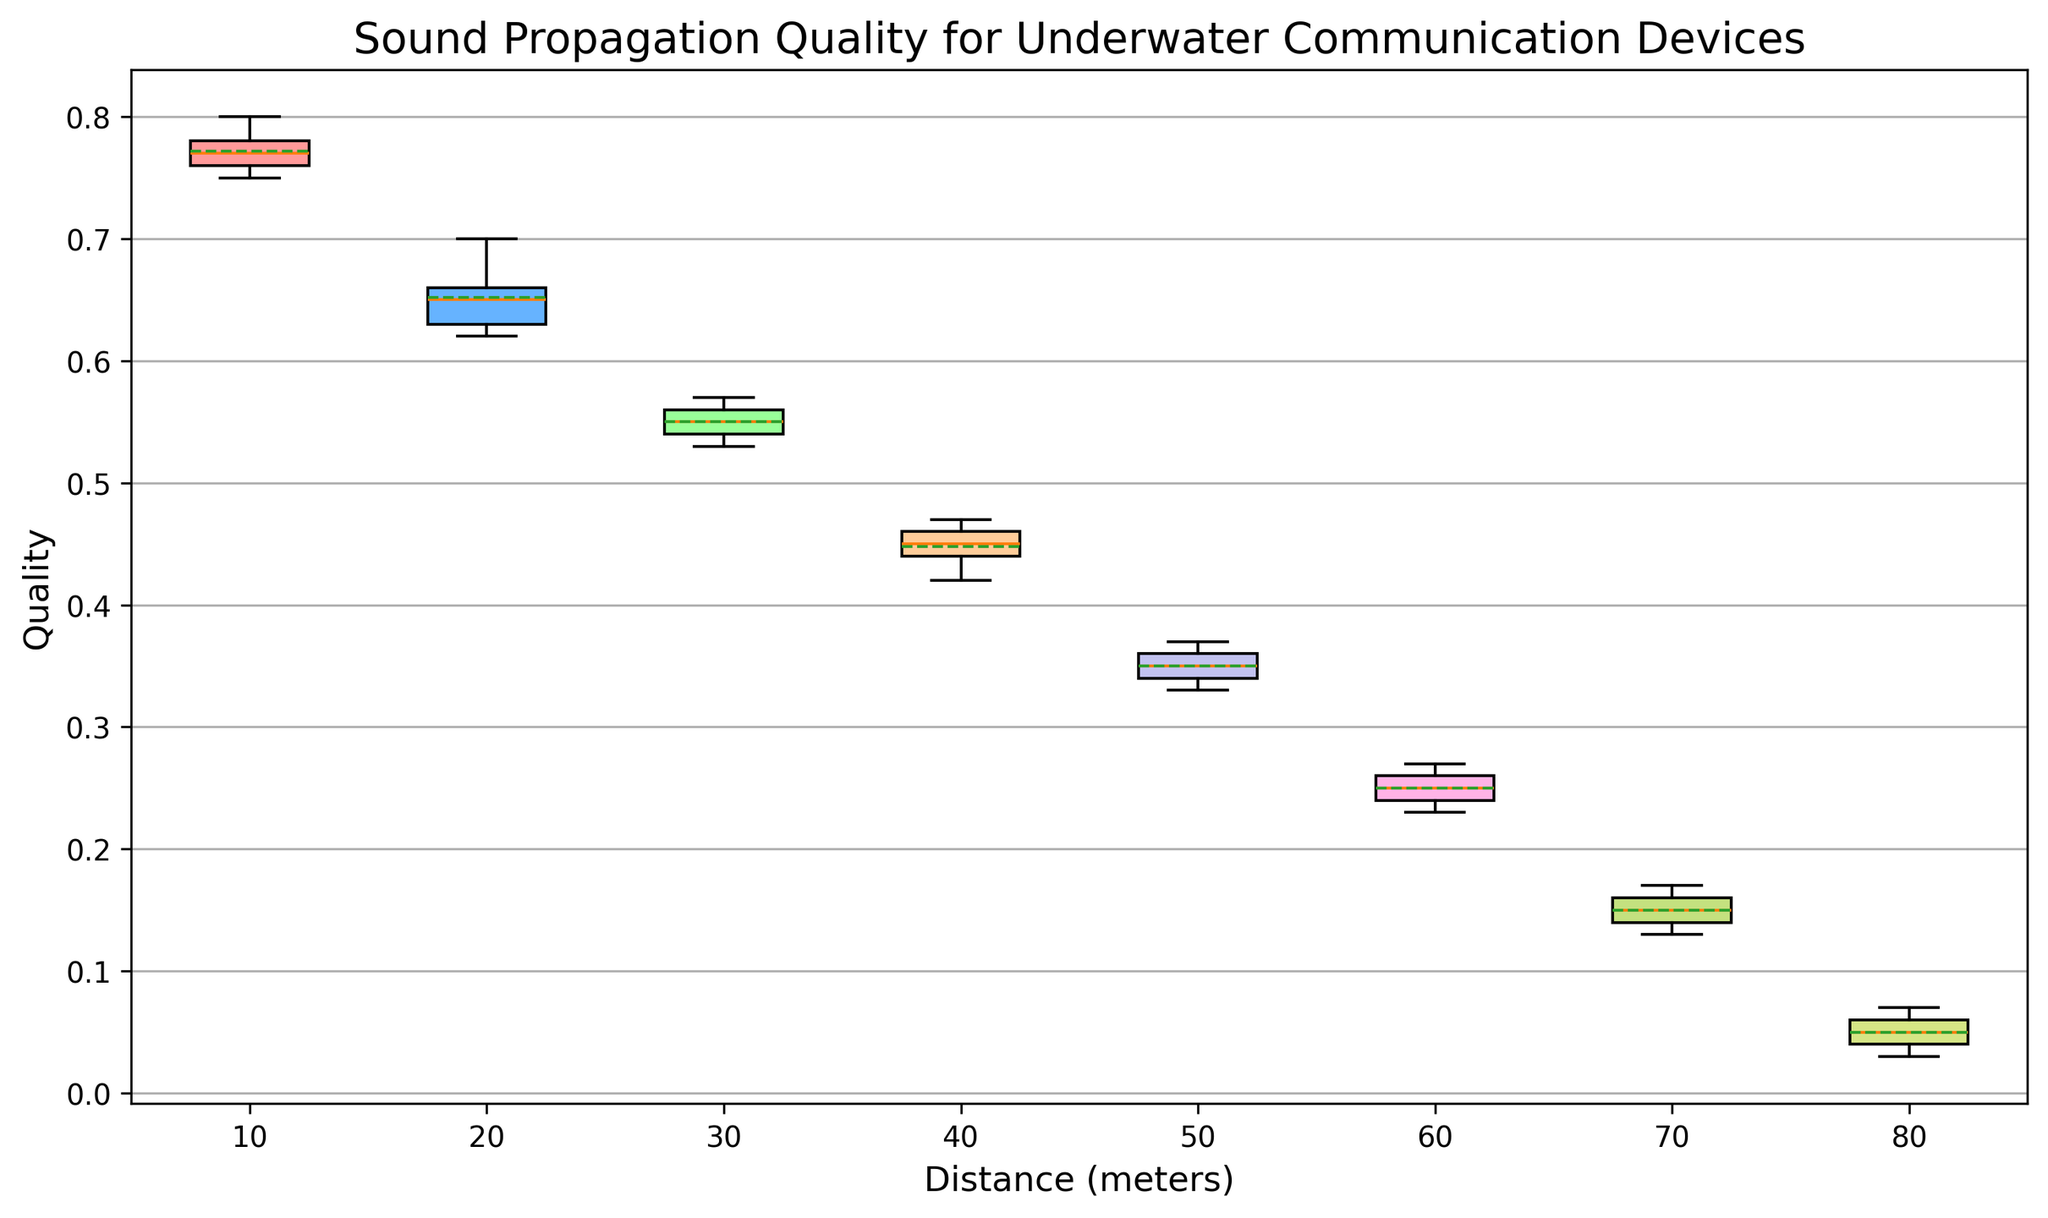Which distance has the highest median quality? First, look at the position of the median line in each of the boxplots. The highest median line indicates the highest median quality. In the figure, the boxplot corresponding to the distance of 10 meters has the highest median line.
Answer: 10 meters What is the difference in the means of the quality between the 10 meters and 80 meters distances? First, identify the mean values indicated by the dashed lines in each of the boxplots for 10 meters and 80 meters. The mean for 10 meters is around 0.77 and for 80 meters is around 0.05. Calculate the difference: 0.77 - 0.05 = 0.72.
Answer: 0.72 At which distance is the interquartile range (IQR) the smallest? The IQR is the range between the first quartile (Q1) and the third quartile (Q3) within a boxplot. Observe each boxplot to see the vertical length of the boxes. The smallest IQR corresponds to the smallest vertical length of a box. For the distances, 80 meters has the smallest box, indicating the smallest IQR.
Answer: 80 meters Which distance shows the greatest spread (range) in quality values? The spread or range is indicated by the length of the whiskers in the boxplot. The distance with the longest whiskers suggests the greatest spread. In the figure, the distance of 10 meters has the longest whiskers, indicating the greatest spread in quality values.
Answer: 10 meters How many distances showed a median quality lower than 0.5? Examine the median lines in each boxplot. If the median line is below 0.5, count those distances. In the figure, the distances 50 meters, 60 meters, 70 meters, and 80 meters all have medians below 0.5.
Answer: 4 distances Which boxplot has the interquartile range including the value 0.6? Check for the boxplots where the box (IQR) spans the value 0.6. From the figure, the boxplot corresponding to the distance of 20 meters includes the value 0.6 within its box.
Answer: 20 meters If you average the median qualities of the distances 30 meters and 50 meters, what is the result? Determine the median values for 30 meters (around 0.55) and 50 meters (around 0.35). Calculate the average: (0.55 + 0.35) / 2 = 0.45.
Answer: 0.45 Which distance has the least variation in quality values? Variation can be observed through the spread of the boxplot and the length of the whiskers. The least variation will be shown by the shortest box and whiskers. The distance of 80 meters has the least variation as it has the smallest spread in the boxplot.
Answer: 80 meters 